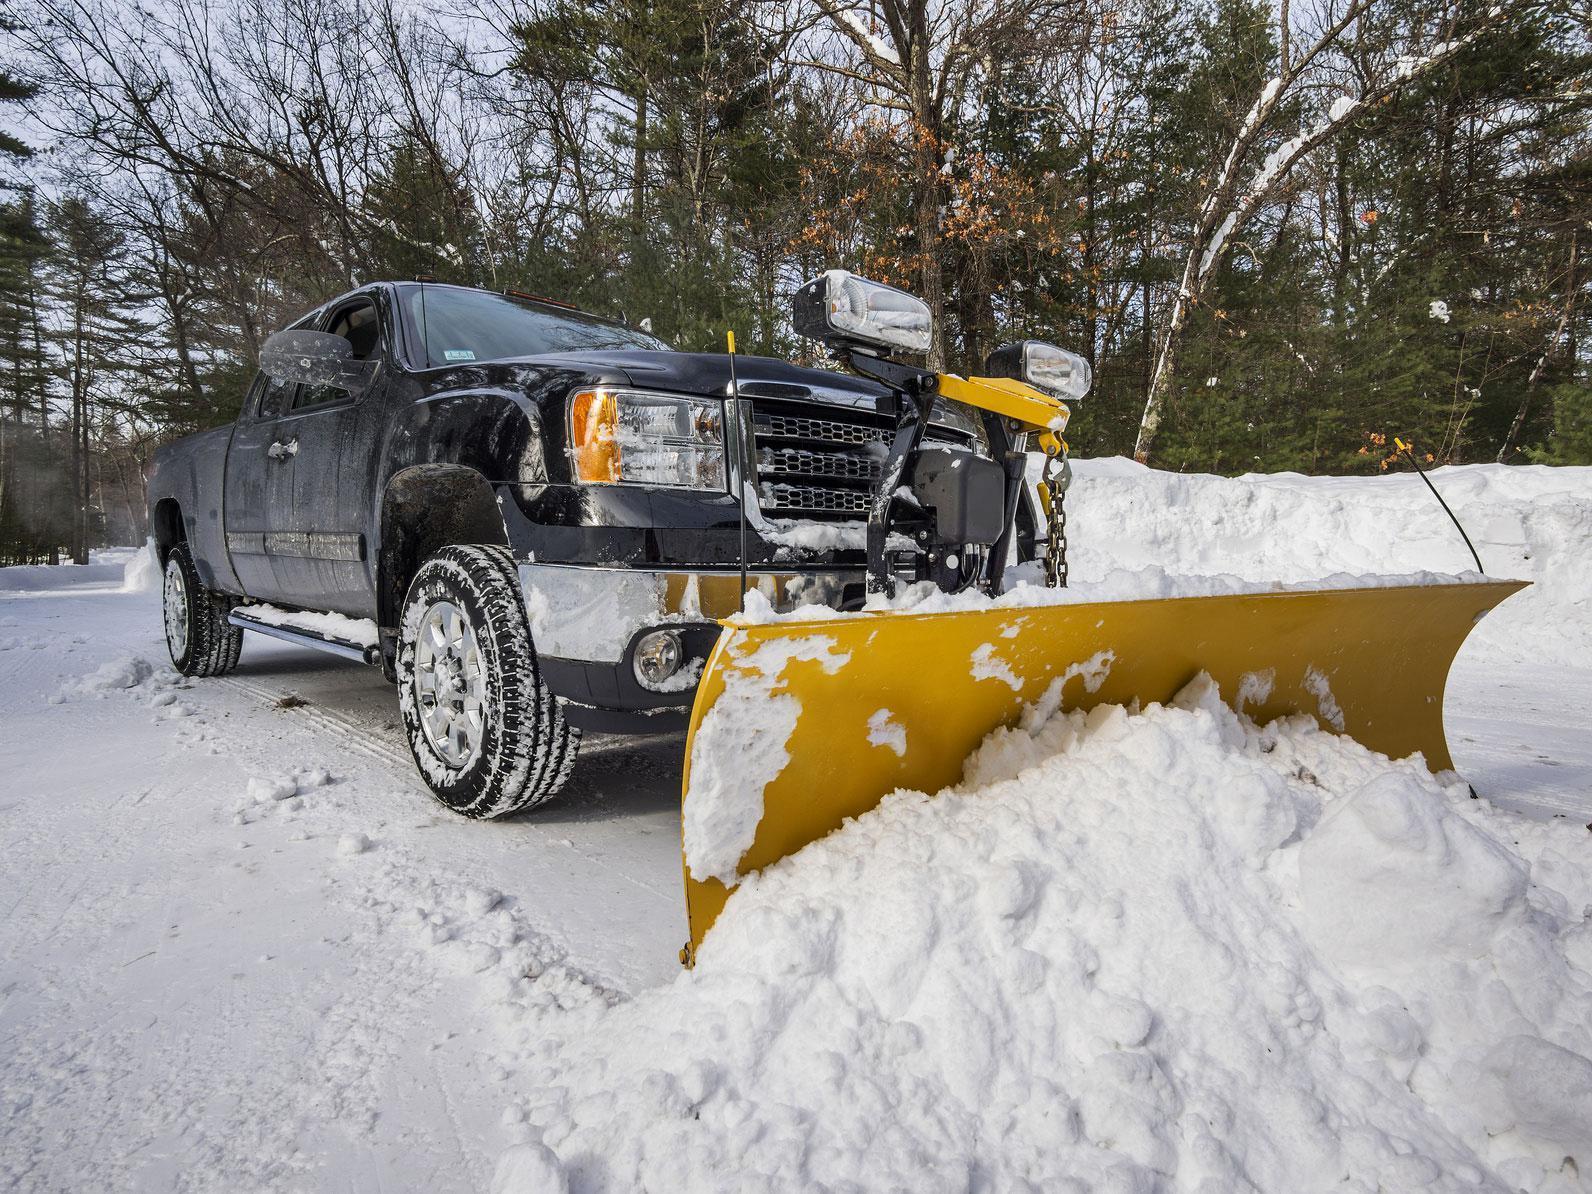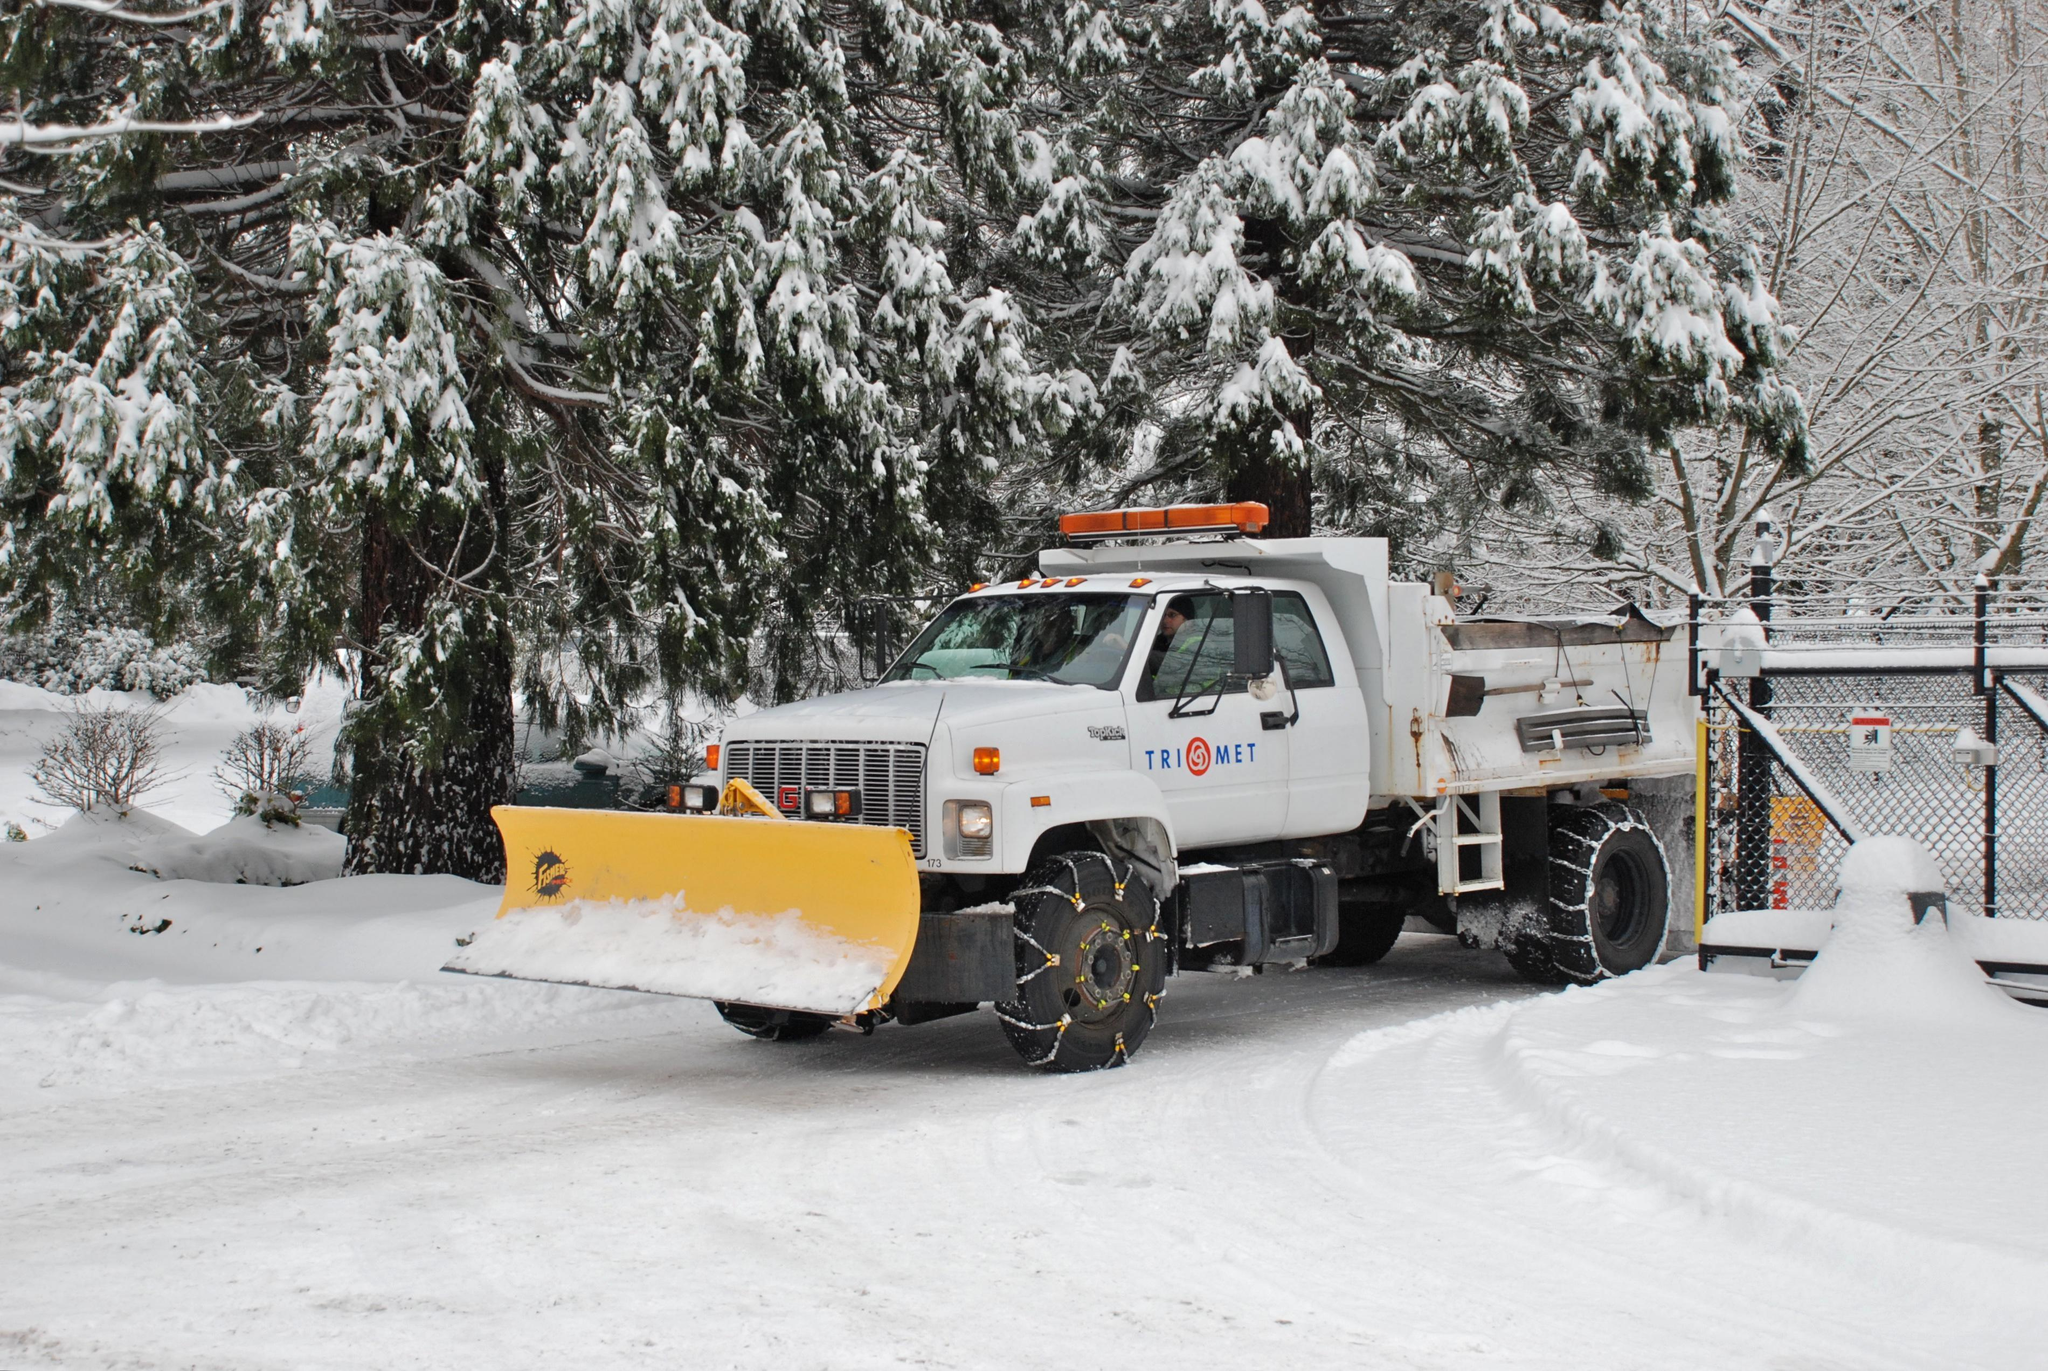The first image is the image on the left, the second image is the image on the right. Analyze the images presented: Is the assertion "At least one of the trucks is pushing a yellow plow through the snow." valid? Answer yes or no. Yes. The first image is the image on the left, the second image is the image on the right. Analyze the images presented: Is the assertion "An image shows a forward-angled dark pickup truck pushing up snow with a plow." valid? Answer yes or no. Yes. 